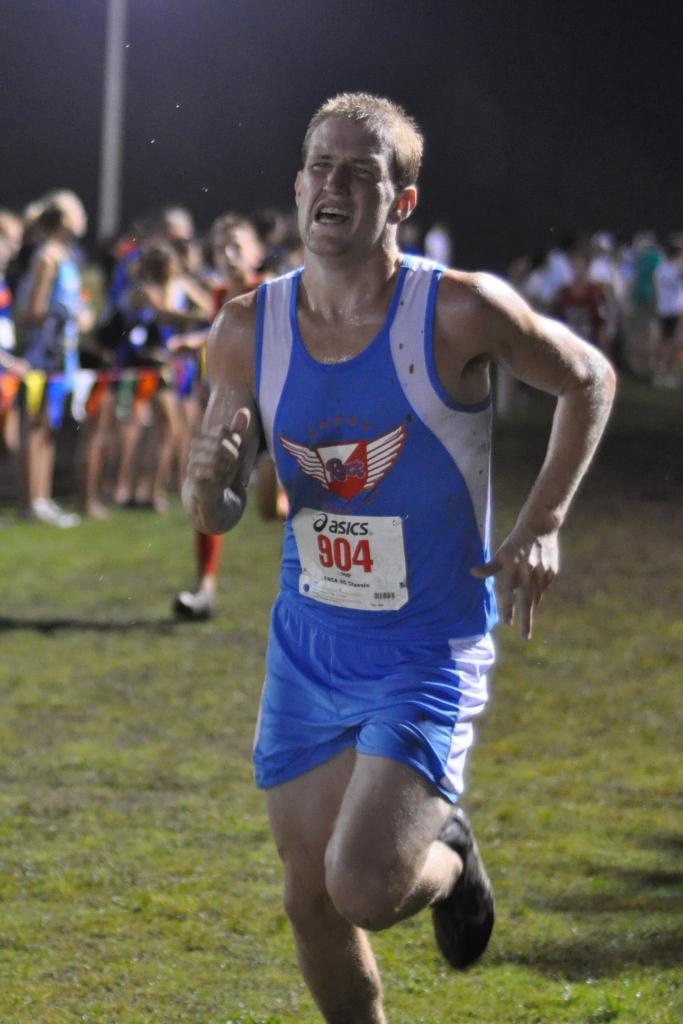Provide a one-sentence caption for the provided image. A runner wearing  number 804 is really struggling in a foot race. 